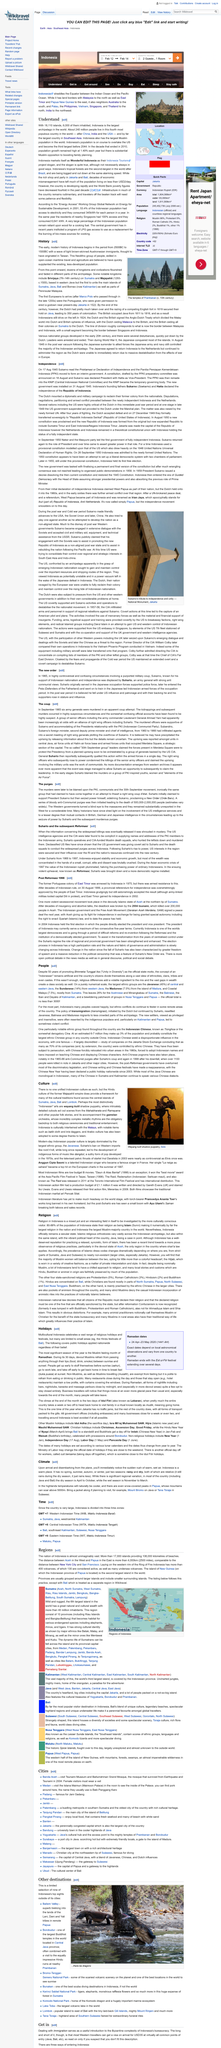Point out several critical features in this image. On June 29, 1965, six army generals were brutally murdered in an apparent coup attempt that shook the nation. Indonesia is made up of over 17,000 islands. Suharto, before seizing power from President Sukamo, supported the president and worked to help him in any way he could. Wayang kulit shadow puppetry is one of the most distinctively Indonesian arts. The three provinces of Indonesia mentioned in the article are Aceh, Papua, and Bali. 